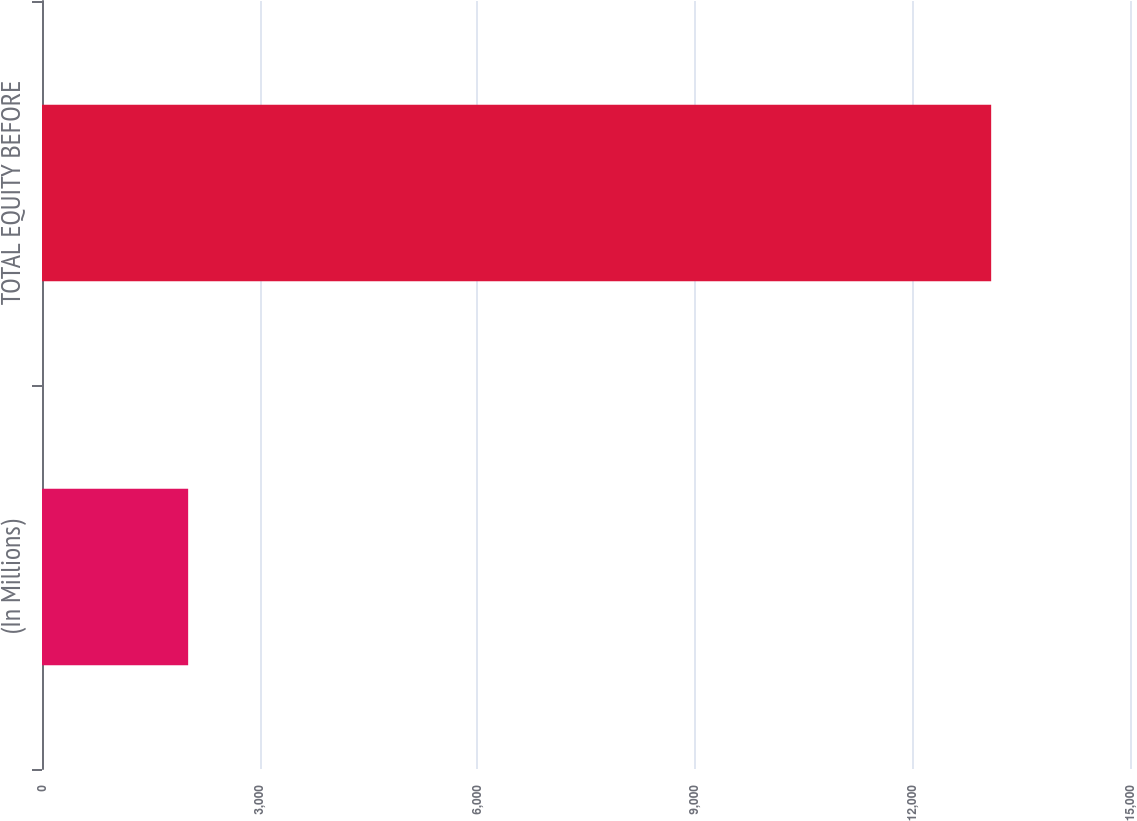<chart> <loc_0><loc_0><loc_500><loc_500><bar_chart><fcel>(In Millions)<fcel>TOTAL EQUITY BEFORE<nl><fcel>2015<fcel>13086<nl></chart> 